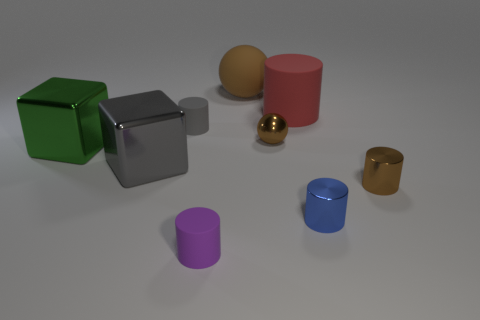What number of small things are red cubes or gray things?
Your response must be concise. 1. Are there more tiny metallic balls on the right side of the gray cylinder than tiny purple rubber objects behind the gray metal thing?
Offer a very short reply. Yes. There is another rubber sphere that is the same color as the small sphere; what is its size?
Offer a terse response. Large. What number of other objects are there of the same size as the gray metal cube?
Offer a very short reply. 3. Does the gray object behind the green shiny thing have the same material as the large cylinder?
Ensure brevity in your answer.  Yes. How many other things are there of the same color as the rubber ball?
Provide a short and direct response. 2. How many other objects are there of the same shape as the tiny blue thing?
Offer a very short reply. 4. Is the shape of the purple rubber thing that is in front of the gray shiny cube the same as the large shiny thing in front of the green shiny thing?
Offer a terse response. No. Are there the same number of tiny gray matte cylinders that are in front of the small brown shiny cylinder and brown matte spheres in front of the small blue metallic cylinder?
Provide a short and direct response. Yes. There is a brown metal object to the left of the matte cylinder that is on the right side of the matte cylinder in front of the small blue object; what is its shape?
Your answer should be compact. Sphere. 